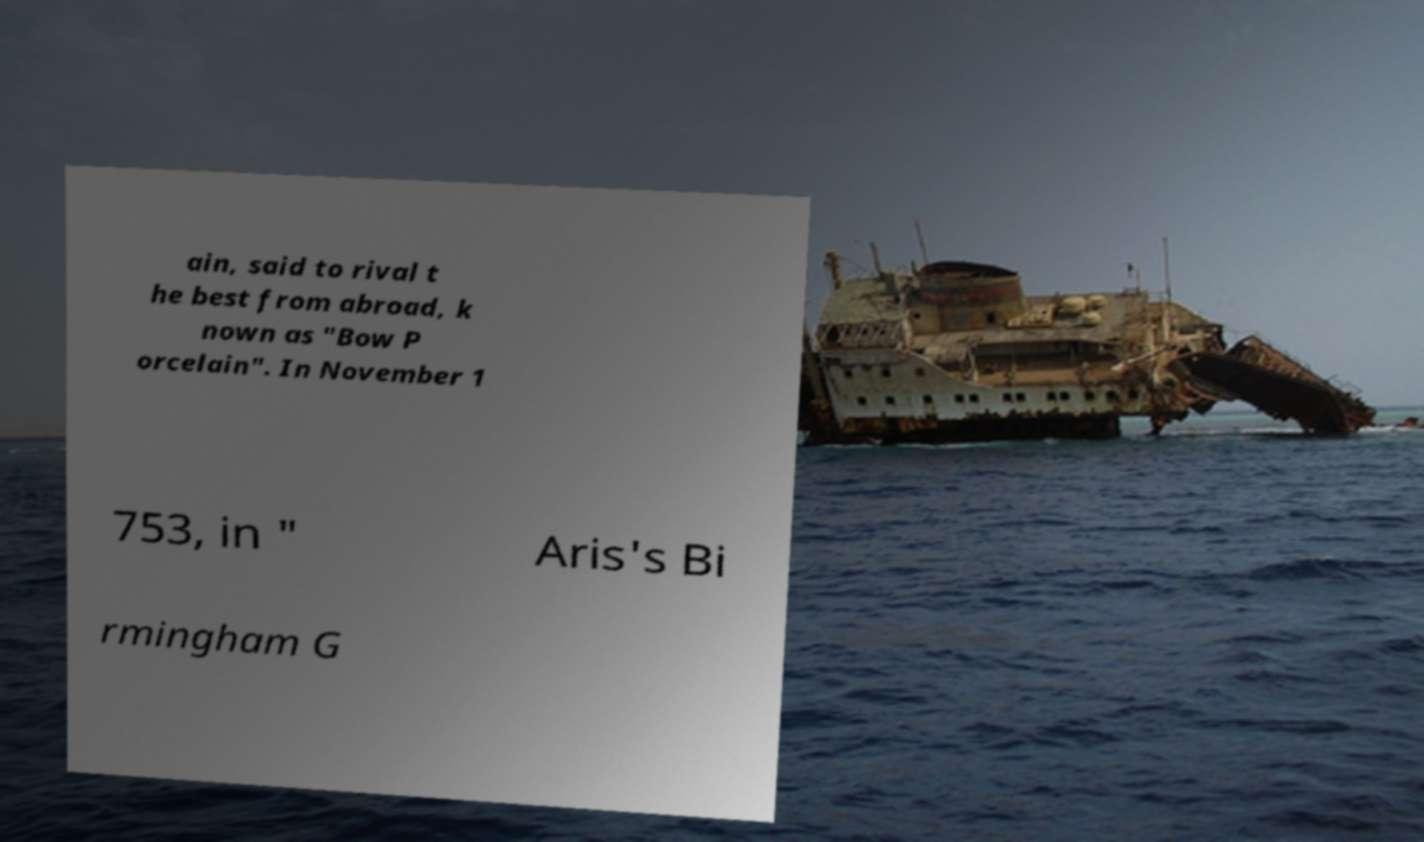Can you read and provide the text displayed in the image?This photo seems to have some interesting text. Can you extract and type it out for me? ain, said to rival t he best from abroad, k nown as "Bow P orcelain". In November 1 753, in " Aris's Bi rmingham G 